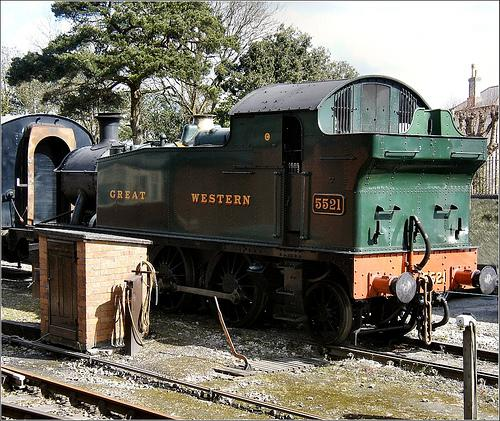Question: where is the train?
Choices:
A. To the right.
B. Tracks.
C. By the station.
D. To the left.
Answer with the letter. Answer: B Question: what is on the tracks?
Choices:
A. A stray cat.
B. Train.
C. A person walking.
D. Gravel.
Answer with the letter. Answer: B Question: who will drive it?
Choices:
A. Engineer.
B. Passenger.
C. Policeman.
D. Conductor.
Answer with the letter. Answer: D 